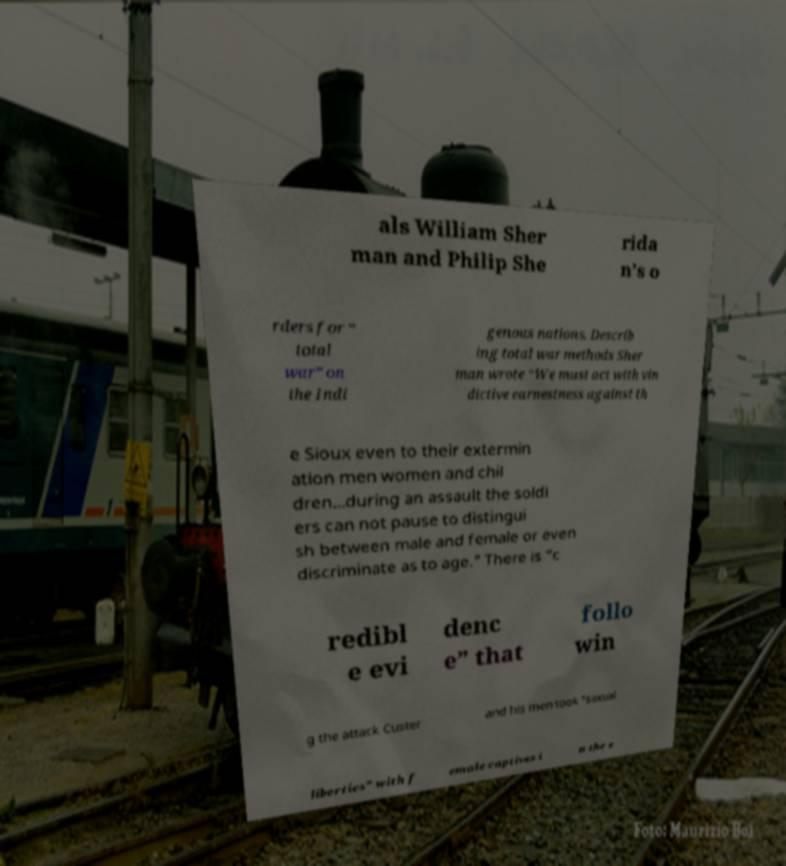I need the written content from this picture converted into text. Can you do that? als William Sher man and Philip She rida n’s o rders for “ total war” on the Indi genous nations. Describ ing total war methods Sher man wrote “We must act with vin dictive earnestness against th e Sioux even to their extermin ation men women and chil dren...during an assault the soldi ers can not pause to distingui sh between male and female or even discriminate as to age." There is “c redibl e evi denc e” that follo win g the attack Custer and his men took “sexual liberties” with f emale captives i n the e 